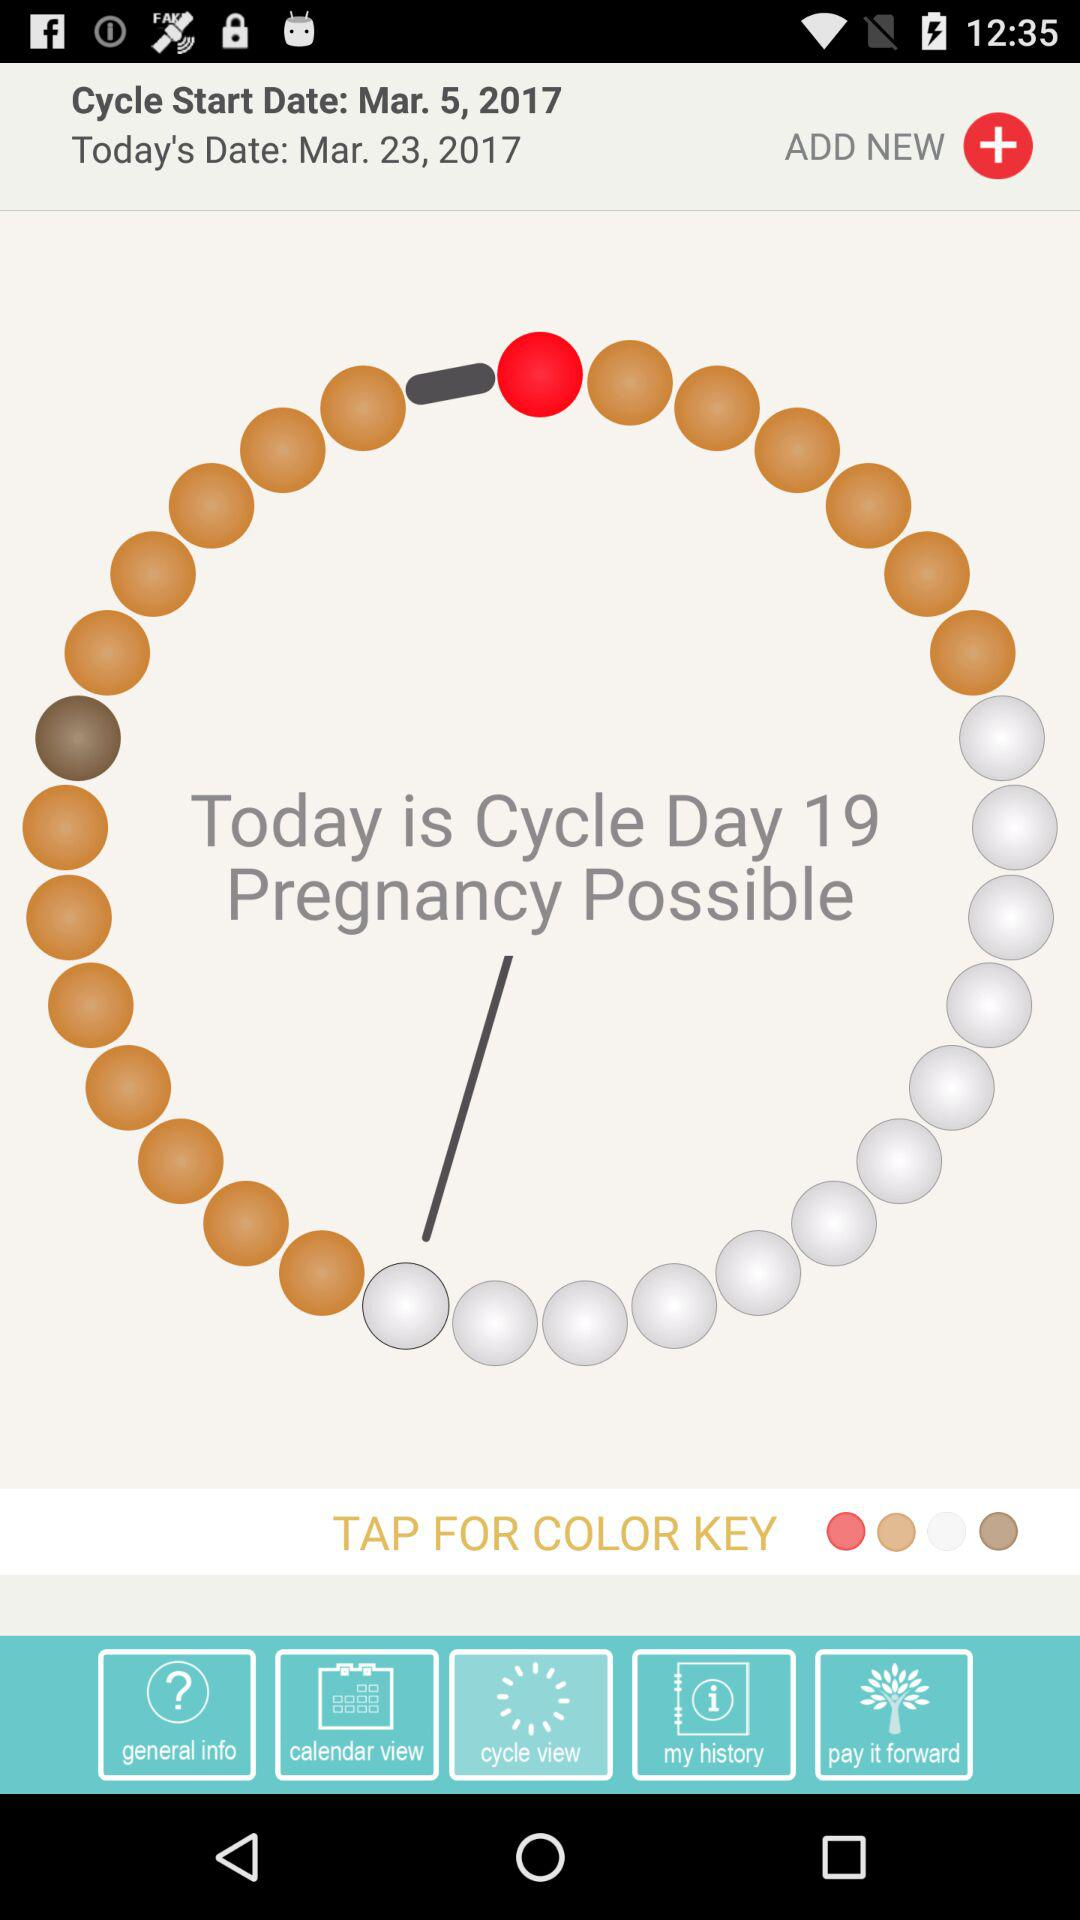What is the cycle start date? The cycle start date is March 5, 2017. 